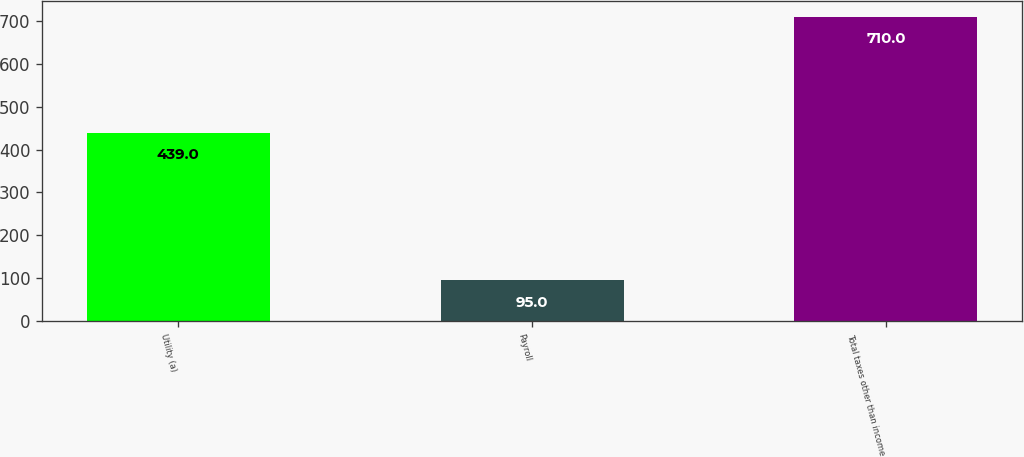Convert chart. <chart><loc_0><loc_0><loc_500><loc_500><bar_chart><fcel>Utility (a)<fcel>Payroll<fcel>Total taxes other than income<nl><fcel>439<fcel>95<fcel>710<nl></chart> 